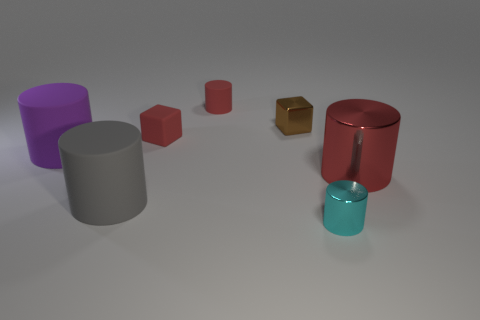Subtract all red rubber cylinders. How many cylinders are left? 4 Subtract 3 cylinders. How many cylinders are left? 2 Subtract all gray cubes. How many red cylinders are left? 2 Add 1 small red cylinders. How many objects exist? 8 Subtract all red cylinders. How many cylinders are left? 3 Subtract all purple cylinders. Subtract all green cubes. How many cylinders are left? 4 Subtract all cubes. How many objects are left? 5 Add 7 tiny metallic blocks. How many tiny metallic blocks are left? 8 Add 4 tiny cylinders. How many tiny cylinders exist? 6 Subtract 0 green spheres. How many objects are left? 7 